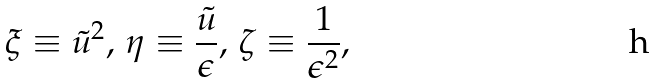<formula> <loc_0><loc_0><loc_500><loc_500>\xi \equiv \tilde { u } ^ { 2 } , \, \eta \equiv \frac { \tilde { u } } { \epsilon } , \, \zeta \equiv \frac { 1 } { \epsilon ^ { 2 } } ,</formula> 